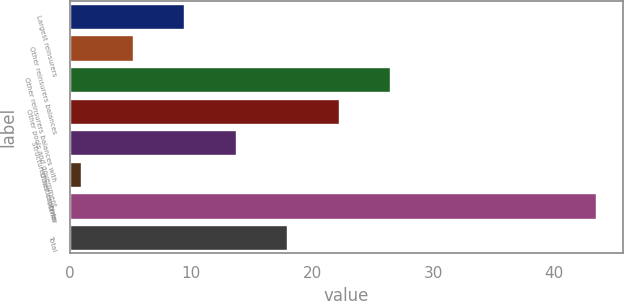Convert chart to OTSL. <chart><loc_0><loc_0><loc_500><loc_500><bar_chart><fcel>Largest reinsurers<fcel>Other reinsurers balances<fcel>Other reinsurers balances with<fcel>Other pools and government<fcel>Structured settlements<fcel>Other captives<fcel>Other<fcel>Total<nl><fcel>9.42<fcel>5.16<fcel>26.46<fcel>22.2<fcel>13.68<fcel>0.9<fcel>43.5<fcel>17.94<nl></chart> 